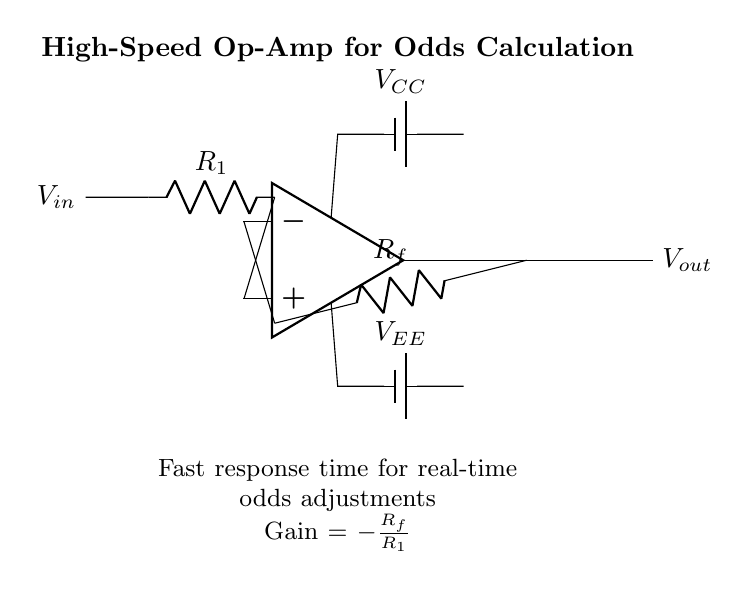What is the input voltage labeled in the circuit? The input voltage is labeled as V_in, indicated on the left side of the circuit diagram, showing where the voltage is applied to the amplifier.
Answer: V_in What is the output voltage of the operational amplifier? The output voltage is labeled as V_out, which is shown at the output terminal of the operational amplifier, indicating the signal produced by the amplifier.
Answer: V_out What is the value of the feedback resistor labeled in the circuit? The feedback resistor in this circuit is labeled as R_f, which connects the output of the op-amp to its inverting input, forming a feedback loop.
Answer: R_f What is the function of the resistor labeled R_1 in the circuit? R_1 is the resistor connected to the non-inverting input of the operational amplifier, which affects the gain of the amplifier as part of the impedance setup for the input signal.
Answer: Input impedance What is the gain formula for the amplifier as shown in the circuit? The gain formula is given as Gain = -R_f/R_1, which indicates the relationship between the feedback resistor and the input resistor for determining the output gain of the amplifier.
Answer: Gain = -R_f/R_1 Why is this operational amplifier designated as high-speed? The designation of high-speed implies that the operational amplifier is designed to have a fast response time, which is critical for real-time data processing in odds calculation systems, allowing quick adjustments to the output.
Answer: Fast response time What are the power supply voltages connected to the op-amp? The power supply voltages labeled in the circuit are V_CC and V_EE, indicating the positive and negative supply connections needed for the operational amplifier to function correctly.
Answer: V_CC and V_EE 